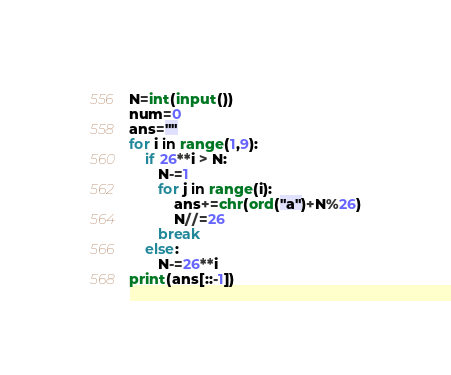<code> <loc_0><loc_0><loc_500><loc_500><_Python_>N=int(input())
num=0
ans=""
for i in range(1,9):
    if 26**i > N:
       N-=1
       for j in range(i):
           ans+=chr(ord("a")+N%26)
           N//=26
       break
    else:
       N-=26**i
print(ans[::-1])
</code> 